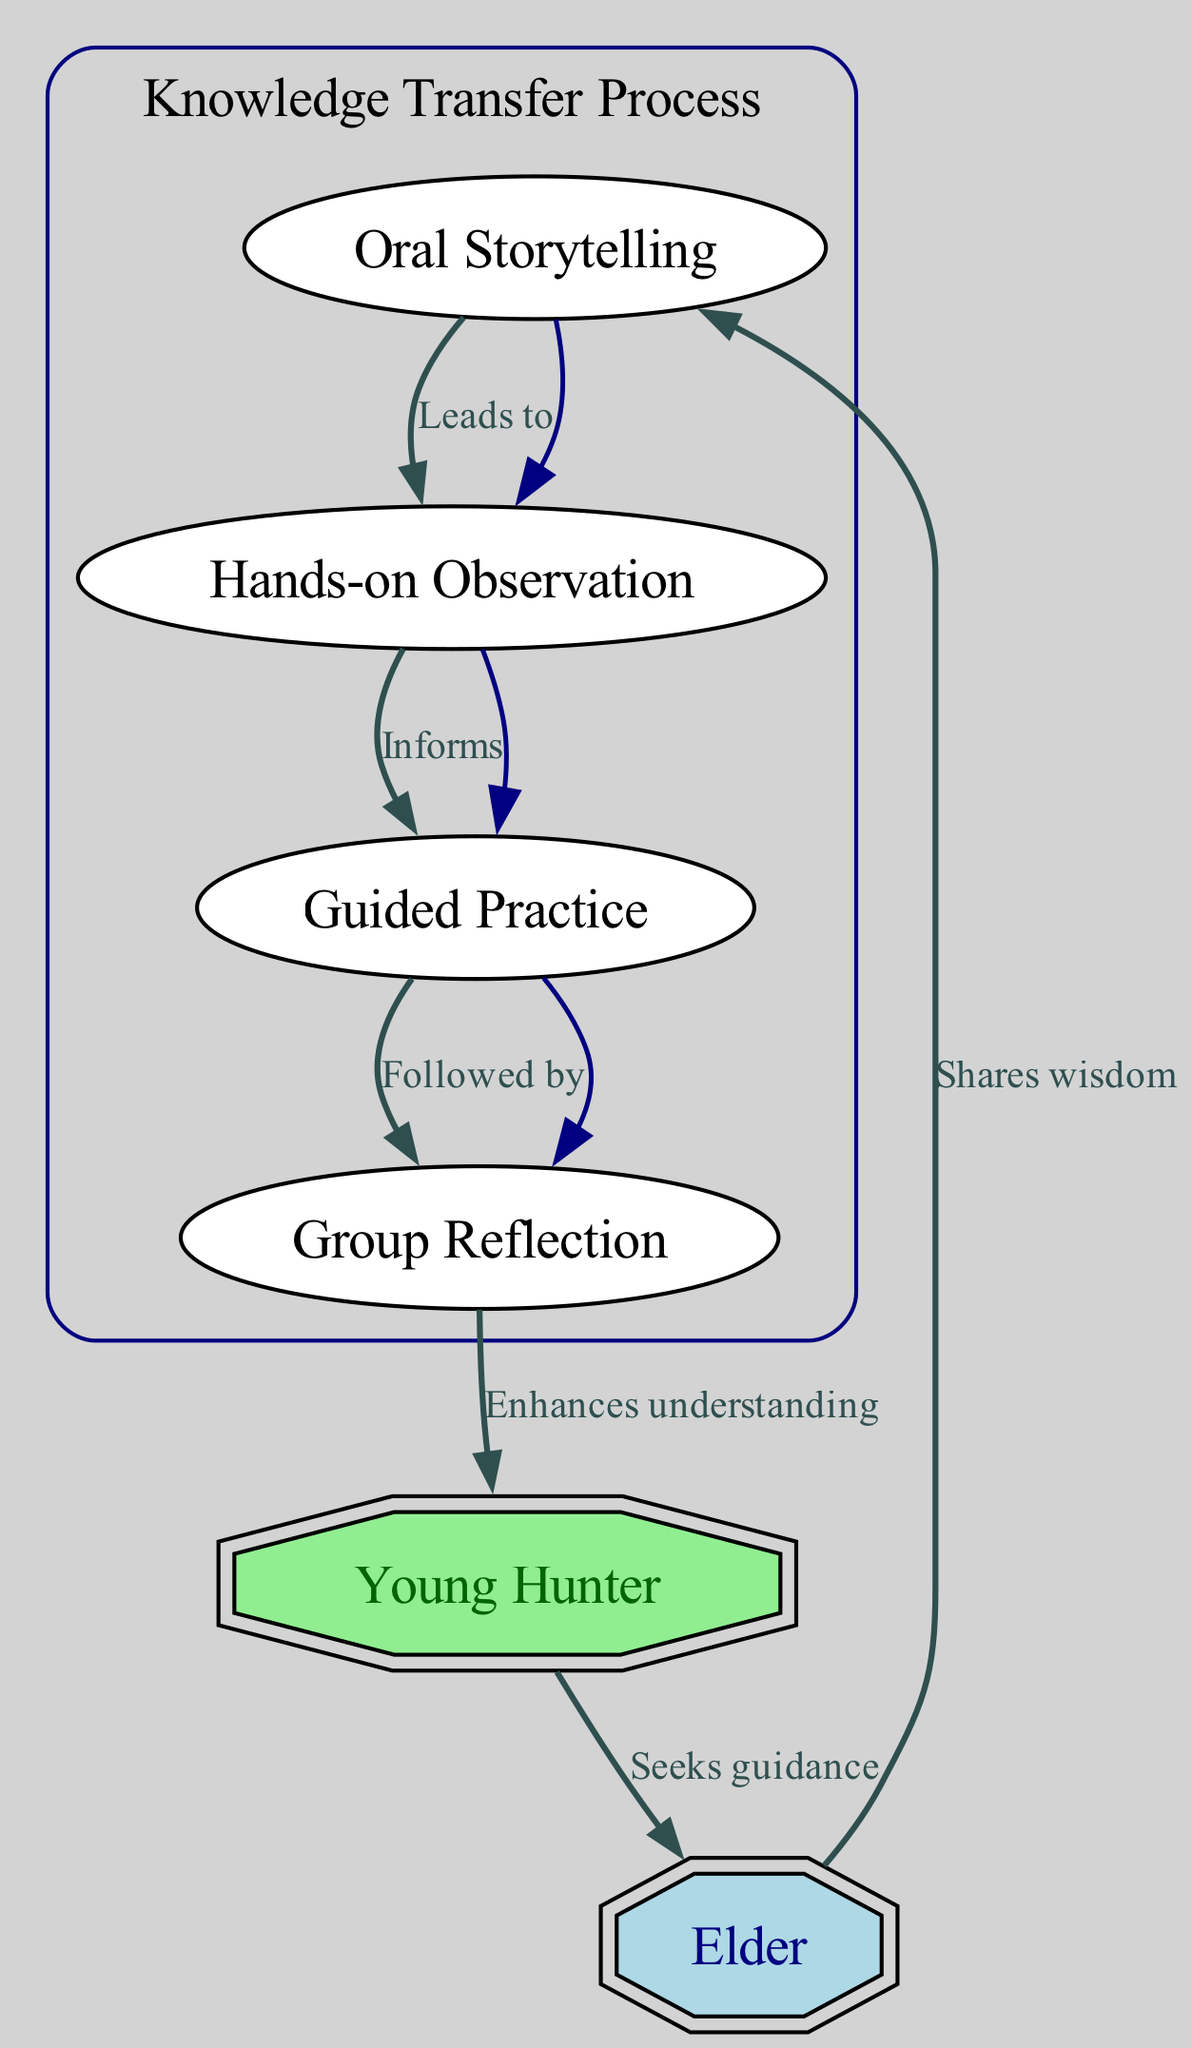What is the starting point of the knowledge transfer process? According to the diagram, the knowledge transfer process begins with the "Elder" node, who shares wisdom with the younger generation.
Answer: Elder How many nodes are present in the diagram? The diagram includes six distinct nodes: Elder, Oral Storytelling, Hands-on Observation, Guided Practice, Group Reflection, and Young Hunter.
Answer: Six What does the "Oral Storytelling" node lead to? The edge from the "Oral Storytelling" node points to the "Hands-on Observation" node, indicating that oral storytelling leads to observation.
Answer: Hands-on Observation What action follows the "Guided Practice" node? Based on the diagram, the action that follows the "Guided Practice" node is "Group Reflection," as indicated by the edge connecting the two nodes.
Answer: Group Reflection What enhances the understanding of the young hunter? The diagram shows that the "Group Reflection" node enhances the understanding of the "Young Hunter," suggesting that reflection is crucial for learning.
Answer: Group Reflection What is the relationship between "Young Hunter" and "Elder"? The diagram indicates a reciprocal relationship where the "Young Hunter" seeks guidance from the "Elder," illustrating the importance of ongoing support in knowledge transfer.
Answer: Seeks guidance Which node discusses hands-on learning? The "Hands-on Observation" node represents hands-on learning, emphasizing that direct observation is a vital part of the knowledge transfer process.
Answer: Hands-on Observation How does "Guided Practice" relate to "Group Reflection"? The "Guided Practice" node directly informs the "Group Reflection" node, indicating that practice precedes reflection, which helps solidify knowledge.
Answer: Follows by What type of knowledge transfer process is represented in the diagram? The diagram represents a traditional knowledge transfer process in the Inuit culture, specifically focused on passing down skills and wisdom from elders to youth.
Answer: Traditional Inuit knowledge transfer process 